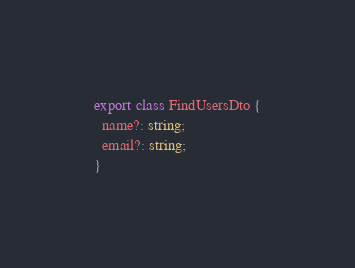<code> <loc_0><loc_0><loc_500><loc_500><_TypeScript_>export class FindUsersDto {
  name?: string;
  email?: string;
}
</code> 